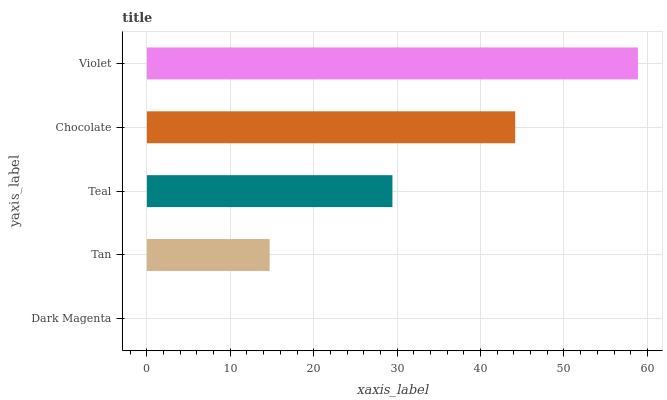Is Dark Magenta the minimum?
Answer yes or no. Yes. Is Violet the maximum?
Answer yes or no. Yes. Is Tan the minimum?
Answer yes or no. No. Is Tan the maximum?
Answer yes or no. No. Is Tan greater than Dark Magenta?
Answer yes or no. Yes. Is Dark Magenta less than Tan?
Answer yes or no. Yes. Is Dark Magenta greater than Tan?
Answer yes or no. No. Is Tan less than Dark Magenta?
Answer yes or no. No. Is Teal the high median?
Answer yes or no. Yes. Is Teal the low median?
Answer yes or no. Yes. Is Dark Magenta the high median?
Answer yes or no. No. Is Chocolate the low median?
Answer yes or no. No. 